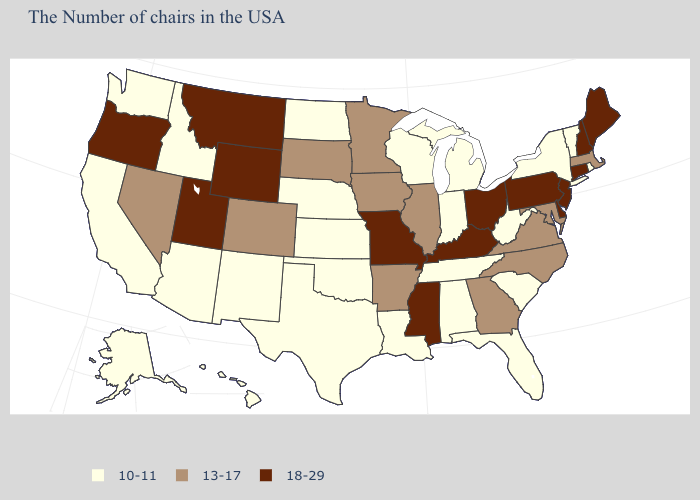Does New Hampshire have the highest value in the USA?
Give a very brief answer. Yes. Does Rhode Island have the lowest value in the Northeast?
Write a very short answer. Yes. Name the states that have a value in the range 18-29?
Quick response, please. Maine, New Hampshire, Connecticut, New Jersey, Delaware, Pennsylvania, Ohio, Kentucky, Mississippi, Missouri, Wyoming, Utah, Montana, Oregon. What is the value of North Dakota?
Give a very brief answer. 10-11. Name the states that have a value in the range 13-17?
Quick response, please. Massachusetts, Maryland, Virginia, North Carolina, Georgia, Illinois, Arkansas, Minnesota, Iowa, South Dakota, Colorado, Nevada. Is the legend a continuous bar?
Write a very short answer. No. Does the first symbol in the legend represent the smallest category?
Concise answer only. Yes. What is the value of Oklahoma?
Concise answer only. 10-11. Name the states that have a value in the range 13-17?
Short answer required. Massachusetts, Maryland, Virginia, North Carolina, Georgia, Illinois, Arkansas, Minnesota, Iowa, South Dakota, Colorado, Nevada. Name the states that have a value in the range 18-29?
Quick response, please. Maine, New Hampshire, Connecticut, New Jersey, Delaware, Pennsylvania, Ohio, Kentucky, Mississippi, Missouri, Wyoming, Utah, Montana, Oregon. What is the lowest value in the West?
Answer briefly. 10-11. Does Arkansas have the highest value in the USA?
Answer briefly. No. Name the states that have a value in the range 13-17?
Give a very brief answer. Massachusetts, Maryland, Virginia, North Carolina, Georgia, Illinois, Arkansas, Minnesota, Iowa, South Dakota, Colorado, Nevada. Among the states that border Iowa , does Wisconsin have the lowest value?
Write a very short answer. Yes. Which states hav the highest value in the West?
Keep it brief. Wyoming, Utah, Montana, Oregon. 